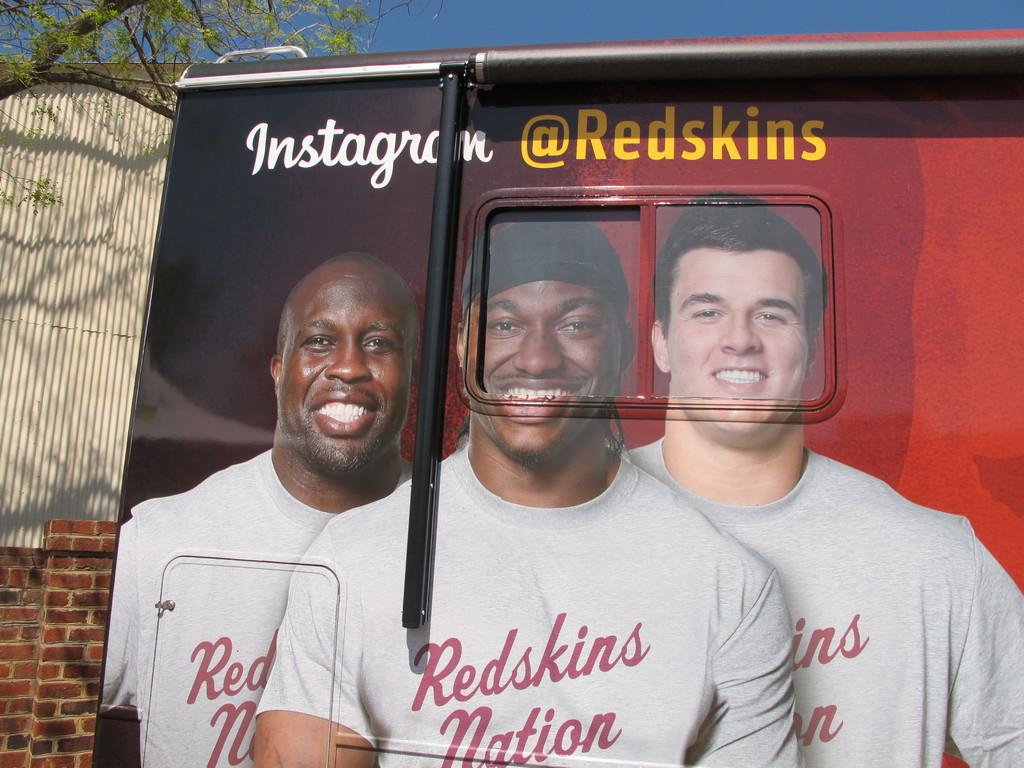What is located in the foreground of the image? There is a poster in the foreground of the image. What structures can be seen in the background of the image? There is a shed and a wall in the background of the image. What type of vegetation is visible at the top of the image? There is a tree visible at the top of the image. What else is visible at the top of the image? The sky is visible at the top of the image. What type of surprise is depicted on the poster in the image? There is no indication of a surprise on the poster in the image, as the facts provided do not mention any specific content on the poster. 